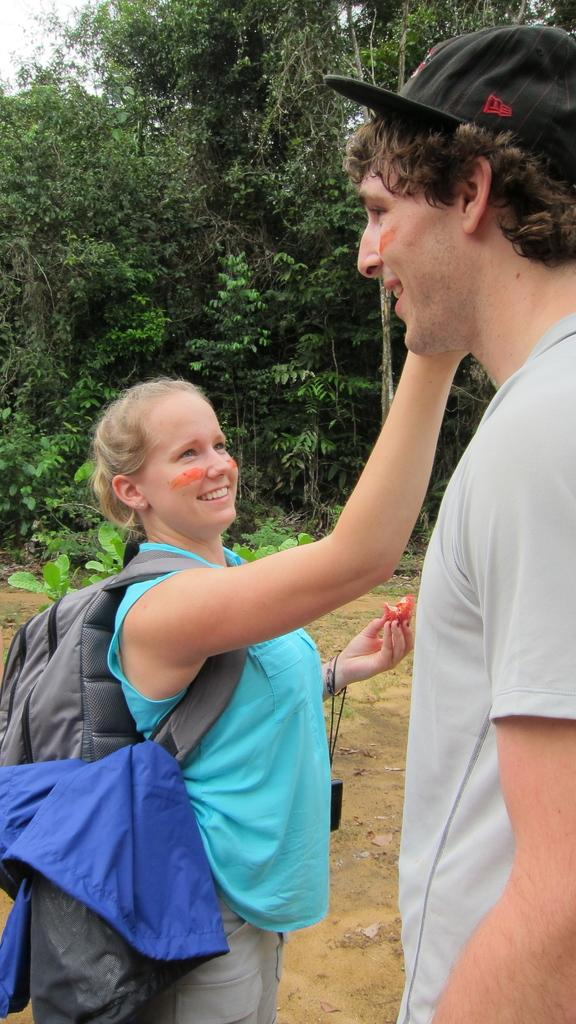How many people are in the image? There are two persons standing in the middle of the image. What are the people doing in the image? The persons are smiling and holding something. What can be seen in the background of the image? There are trees visible in the background of the image. What type of cattle can be seen grazing in the image? There is no cattle present in the image; it features two persons standing and smiling. Is there a meeting taking place in the image? There is no indication of a meeting in the image; the two persons are simply standing and smiling. 